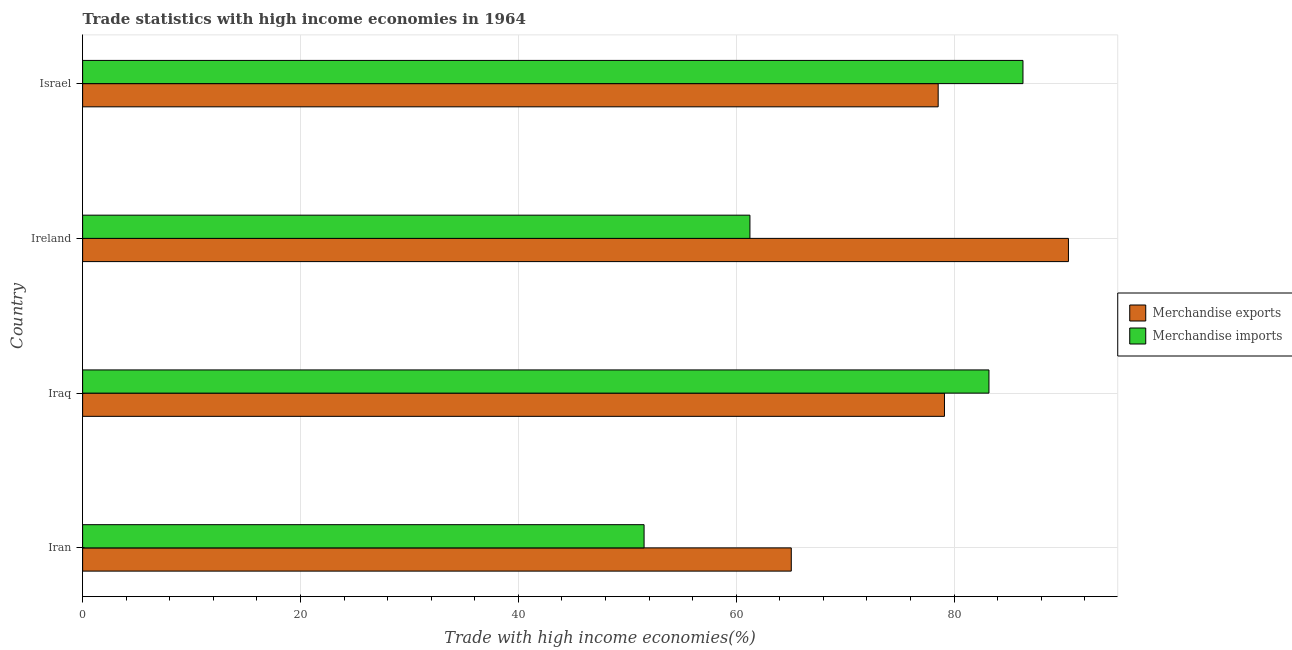How many groups of bars are there?
Provide a succinct answer. 4. Are the number of bars per tick equal to the number of legend labels?
Keep it short and to the point. Yes. Are the number of bars on each tick of the Y-axis equal?
Offer a very short reply. Yes. How many bars are there on the 3rd tick from the bottom?
Give a very brief answer. 2. What is the label of the 1st group of bars from the top?
Ensure brevity in your answer.  Israel. In how many cases, is the number of bars for a given country not equal to the number of legend labels?
Give a very brief answer. 0. What is the merchandise exports in Iraq?
Keep it short and to the point. 79.11. Across all countries, what is the maximum merchandise imports?
Ensure brevity in your answer.  86.32. Across all countries, what is the minimum merchandise exports?
Your answer should be very brief. 65.05. In which country was the merchandise exports maximum?
Your response must be concise. Ireland. In which country was the merchandise exports minimum?
Keep it short and to the point. Iran. What is the total merchandise imports in the graph?
Keep it short and to the point. 282.31. What is the difference between the merchandise imports in Ireland and that in Israel?
Provide a short and direct response. -25.06. What is the difference between the merchandise exports in Iran and the merchandise imports in Israel?
Provide a short and direct response. -21.27. What is the average merchandise exports per country?
Offer a very short reply. 78.3. What is the difference between the merchandise exports and merchandise imports in Israel?
Ensure brevity in your answer.  -7.78. In how many countries, is the merchandise exports greater than 36 %?
Provide a short and direct response. 4. What is the ratio of the merchandise imports in Iraq to that in Ireland?
Provide a short and direct response. 1.36. What is the difference between the highest and the second highest merchandise imports?
Provide a succinct answer. 3.12. What is the difference between the highest and the lowest merchandise exports?
Provide a succinct answer. 25.44. In how many countries, is the merchandise exports greater than the average merchandise exports taken over all countries?
Provide a short and direct response. 3. Is the sum of the merchandise exports in Iran and Israel greater than the maximum merchandise imports across all countries?
Ensure brevity in your answer.  Yes. What does the 2nd bar from the top in Iran represents?
Keep it short and to the point. Merchandise exports. What does the 1st bar from the bottom in Ireland represents?
Make the answer very short. Merchandise exports. How many bars are there?
Your answer should be very brief. 8. Are all the bars in the graph horizontal?
Your answer should be compact. Yes. What is the difference between two consecutive major ticks on the X-axis?
Make the answer very short. 20. Are the values on the major ticks of X-axis written in scientific E-notation?
Your answer should be very brief. No. Does the graph contain any zero values?
Offer a very short reply. No. Does the graph contain grids?
Your answer should be compact. Yes. How many legend labels are there?
Provide a short and direct response. 2. How are the legend labels stacked?
Offer a terse response. Vertical. What is the title of the graph?
Offer a very short reply. Trade statistics with high income economies in 1964. What is the label or title of the X-axis?
Your answer should be very brief. Trade with high income economies(%). What is the label or title of the Y-axis?
Offer a very short reply. Country. What is the Trade with high income economies(%) of Merchandise exports in Iran?
Make the answer very short. 65.05. What is the Trade with high income economies(%) in Merchandise imports in Iran?
Offer a terse response. 51.54. What is the Trade with high income economies(%) in Merchandise exports in Iraq?
Provide a short and direct response. 79.11. What is the Trade with high income economies(%) in Merchandise imports in Iraq?
Keep it short and to the point. 83.2. What is the Trade with high income economies(%) in Merchandise exports in Ireland?
Your response must be concise. 90.49. What is the Trade with high income economies(%) in Merchandise imports in Ireland?
Make the answer very short. 61.26. What is the Trade with high income economies(%) of Merchandise exports in Israel?
Keep it short and to the point. 78.53. What is the Trade with high income economies(%) in Merchandise imports in Israel?
Provide a succinct answer. 86.32. Across all countries, what is the maximum Trade with high income economies(%) of Merchandise exports?
Offer a terse response. 90.49. Across all countries, what is the maximum Trade with high income economies(%) in Merchandise imports?
Keep it short and to the point. 86.32. Across all countries, what is the minimum Trade with high income economies(%) of Merchandise exports?
Keep it short and to the point. 65.05. Across all countries, what is the minimum Trade with high income economies(%) of Merchandise imports?
Your answer should be very brief. 51.54. What is the total Trade with high income economies(%) in Merchandise exports in the graph?
Your answer should be very brief. 313.19. What is the total Trade with high income economies(%) of Merchandise imports in the graph?
Provide a short and direct response. 282.31. What is the difference between the Trade with high income economies(%) of Merchandise exports in Iran and that in Iraq?
Your response must be concise. -14.06. What is the difference between the Trade with high income economies(%) in Merchandise imports in Iran and that in Iraq?
Provide a succinct answer. -31.66. What is the difference between the Trade with high income economies(%) in Merchandise exports in Iran and that in Ireland?
Offer a very short reply. -25.44. What is the difference between the Trade with high income economies(%) in Merchandise imports in Iran and that in Ireland?
Offer a terse response. -9.72. What is the difference between the Trade with high income economies(%) in Merchandise exports in Iran and that in Israel?
Ensure brevity in your answer.  -13.48. What is the difference between the Trade with high income economies(%) of Merchandise imports in Iran and that in Israel?
Your response must be concise. -34.78. What is the difference between the Trade with high income economies(%) in Merchandise exports in Iraq and that in Ireland?
Ensure brevity in your answer.  -11.38. What is the difference between the Trade with high income economies(%) of Merchandise imports in Iraq and that in Ireland?
Keep it short and to the point. 21.94. What is the difference between the Trade with high income economies(%) in Merchandise exports in Iraq and that in Israel?
Keep it short and to the point. 0.58. What is the difference between the Trade with high income economies(%) of Merchandise imports in Iraq and that in Israel?
Provide a succinct answer. -3.12. What is the difference between the Trade with high income economies(%) in Merchandise exports in Ireland and that in Israel?
Keep it short and to the point. 11.96. What is the difference between the Trade with high income economies(%) of Merchandise imports in Ireland and that in Israel?
Offer a very short reply. -25.06. What is the difference between the Trade with high income economies(%) of Merchandise exports in Iran and the Trade with high income economies(%) of Merchandise imports in Iraq?
Provide a succinct answer. -18.15. What is the difference between the Trade with high income economies(%) in Merchandise exports in Iran and the Trade with high income economies(%) in Merchandise imports in Ireland?
Keep it short and to the point. 3.79. What is the difference between the Trade with high income economies(%) in Merchandise exports in Iran and the Trade with high income economies(%) in Merchandise imports in Israel?
Offer a terse response. -21.27. What is the difference between the Trade with high income economies(%) in Merchandise exports in Iraq and the Trade with high income economies(%) in Merchandise imports in Ireland?
Provide a succinct answer. 17.86. What is the difference between the Trade with high income economies(%) of Merchandise exports in Iraq and the Trade with high income economies(%) of Merchandise imports in Israel?
Your answer should be very brief. -7.21. What is the difference between the Trade with high income economies(%) in Merchandise exports in Ireland and the Trade with high income economies(%) in Merchandise imports in Israel?
Give a very brief answer. 4.17. What is the average Trade with high income economies(%) of Merchandise exports per country?
Offer a terse response. 78.3. What is the average Trade with high income economies(%) of Merchandise imports per country?
Provide a succinct answer. 70.58. What is the difference between the Trade with high income economies(%) in Merchandise exports and Trade with high income economies(%) in Merchandise imports in Iran?
Ensure brevity in your answer.  13.51. What is the difference between the Trade with high income economies(%) in Merchandise exports and Trade with high income economies(%) in Merchandise imports in Iraq?
Your response must be concise. -4.08. What is the difference between the Trade with high income economies(%) in Merchandise exports and Trade with high income economies(%) in Merchandise imports in Ireland?
Your answer should be very brief. 29.24. What is the difference between the Trade with high income economies(%) of Merchandise exports and Trade with high income economies(%) of Merchandise imports in Israel?
Offer a very short reply. -7.78. What is the ratio of the Trade with high income economies(%) of Merchandise exports in Iran to that in Iraq?
Offer a very short reply. 0.82. What is the ratio of the Trade with high income economies(%) of Merchandise imports in Iran to that in Iraq?
Offer a terse response. 0.62. What is the ratio of the Trade with high income economies(%) in Merchandise exports in Iran to that in Ireland?
Give a very brief answer. 0.72. What is the ratio of the Trade with high income economies(%) in Merchandise imports in Iran to that in Ireland?
Give a very brief answer. 0.84. What is the ratio of the Trade with high income economies(%) in Merchandise exports in Iran to that in Israel?
Your answer should be very brief. 0.83. What is the ratio of the Trade with high income economies(%) of Merchandise imports in Iran to that in Israel?
Ensure brevity in your answer.  0.6. What is the ratio of the Trade with high income economies(%) in Merchandise exports in Iraq to that in Ireland?
Offer a terse response. 0.87. What is the ratio of the Trade with high income economies(%) of Merchandise imports in Iraq to that in Ireland?
Offer a terse response. 1.36. What is the ratio of the Trade with high income economies(%) in Merchandise exports in Iraq to that in Israel?
Provide a succinct answer. 1.01. What is the ratio of the Trade with high income economies(%) in Merchandise imports in Iraq to that in Israel?
Your response must be concise. 0.96. What is the ratio of the Trade with high income economies(%) in Merchandise exports in Ireland to that in Israel?
Make the answer very short. 1.15. What is the ratio of the Trade with high income economies(%) in Merchandise imports in Ireland to that in Israel?
Provide a succinct answer. 0.71. What is the difference between the highest and the second highest Trade with high income economies(%) of Merchandise exports?
Your response must be concise. 11.38. What is the difference between the highest and the second highest Trade with high income economies(%) in Merchandise imports?
Provide a succinct answer. 3.12. What is the difference between the highest and the lowest Trade with high income economies(%) in Merchandise exports?
Offer a very short reply. 25.44. What is the difference between the highest and the lowest Trade with high income economies(%) in Merchandise imports?
Your response must be concise. 34.78. 